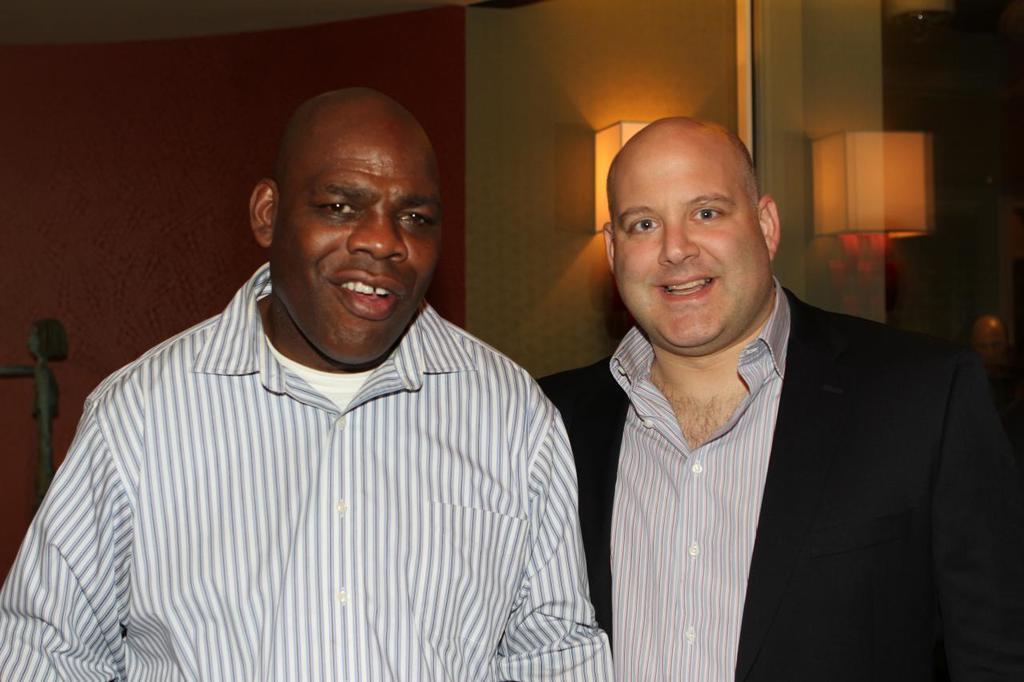Can you describe this image briefly? In this image I can see two people with different color dresses. In the background I can see the lights and the wall. 